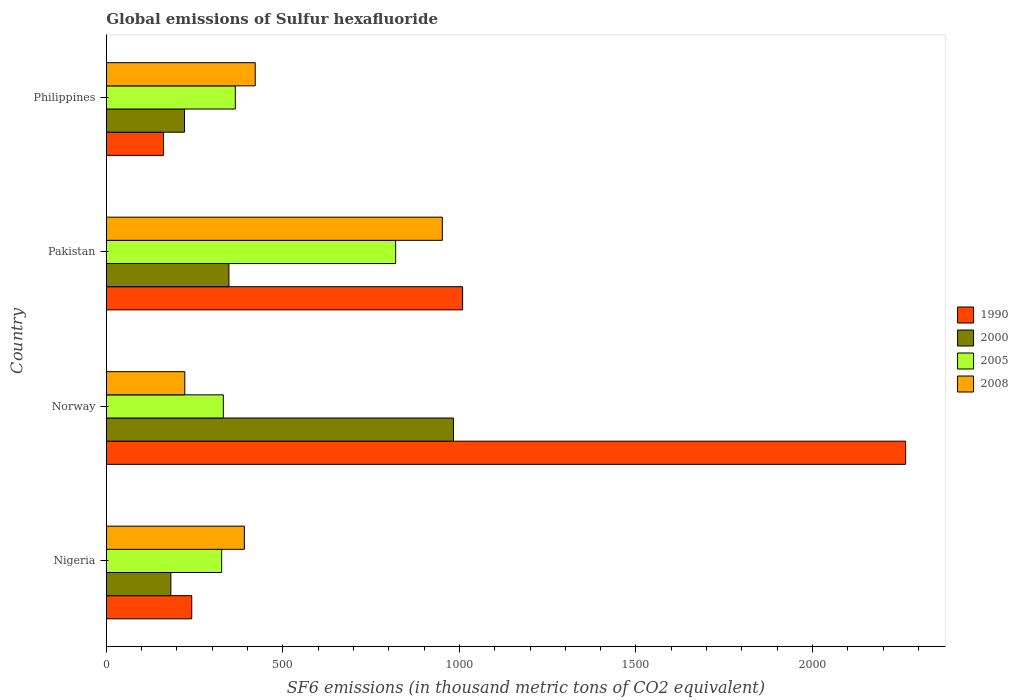How many different coloured bars are there?
Keep it short and to the point. 4. Are the number of bars per tick equal to the number of legend labels?
Your answer should be compact. Yes. How many bars are there on the 4th tick from the bottom?
Offer a very short reply. 4. What is the label of the 1st group of bars from the top?
Your answer should be very brief. Philippines. In how many cases, is the number of bars for a given country not equal to the number of legend labels?
Keep it short and to the point. 0. What is the global emissions of Sulfur hexafluoride in 2005 in Pakistan?
Your response must be concise. 819.4. Across all countries, what is the maximum global emissions of Sulfur hexafluoride in 2008?
Ensure brevity in your answer.  951.6. Across all countries, what is the minimum global emissions of Sulfur hexafluoride in 2005?
Offer a very short reply. 326.6. In which country was the global emissions of Sulfur hexafluoride in 1990 maximum?
Offer a very short reply. Norway. What is the total global emissions of Sulfur hexafluoride in 2000 in the graph?
Make the answer very short. 1734.6. What is the difference between the global emissions of Sulfur hexafluoride in 1990 in Nigeria and that in Norway?
Offer a very short reply. -2021.7. What is the difference between the global emissions of Sulfur hexafluoride in 2000 in Philippines and the global emissions of Sulfur hexafluoride in 2008 in Norway?
Offer a very short reply. -0.8. What is the average global emissions of Sulfur hexafluoride in 2005 per country?
Offer a very short reply. 460.68. What is the difference between the global emissions of Sulfur hexafluoride in 2000 and global emissions of Sulfur hexafluoride in 2005 in Philippines?
Keep it short and to the point. -143.9. What is the ratio of the global emissions of Sulfur hexafluoride in 1990 in Norway to that in Philippines?
Give a very brief answer. 13.98. Is the difference between the global emissions of Sulfur hexafluoride in 2000 in Pakistan and Philippines greater than the difference between the global emissions of Sulfur hexafluoride in 2005 in Pakistan and Philippines?
Provide a succinct answer. No. What is the difference between the highest and the second highest global emissions of Sulfur hexafluoride in 2005?
Offer a terse response. 454.1. What is the difference between the highest and the lowest global emissions of Sulfur hexafluoride in 1990?
Ensure brevity in your answer.  2101.7. Is the sum of the global emissions of Sulfur hexafluoride in 2000 in Nigeria and Pakistan greater than the maximum global emissions of Sulfur hexafluoride in 2008 across all countries?
Give a very brief answer. No. What does the 1st bar from the bottom in Nigeria represents?
Your answer should be compact. 1990. Are all the bars in the graph horizontal?
Provide a succinct answer. Yes. How many countries are there in the graph?
Your answer should be very brief. 4. Does the graph contain any zero values?
Make the answer very short. No. Does the graph contain grids?
Make the answer very short. No. How many legend labels are there?
Your answer should be compact. 4. How are the legend labels stacked?
Make the answer very short. Vertical. What is the title of the graph?
Provide a short and direct response. Global emissions of Sulfur hexafluoride. What is the label or title of the X-axis?
Keep it short and to the point. SF6 emissions (in thousand metric tons of CO2 equivalent). What is the SF6 emissions (in thousand metric tons of CO2 equivalent) in 1990 in Nigeria?
Offer a terse response. 241.9. What is the SF6 emissions (in thousand metric tons of CO2 equivalent) of 2000 in Nigeria?
Provide a short and direct response. 182.8. What is the SF6 emissions (in thousand metric tons of CO2 equivalent) of 2005 in Nigeria?
Your answer should be compact. 326.6. What is the SF6 emissions (in thousand metric tons of CO2 equivalent) in 2008 in Nigeria?
Keep it short and to the point. 390.9. What is the SF6 emissions (in thousand metric tons of CO2 equivalent) of 1990 in Norway?
Offer a terse response. 2263.6. What is the SF6 emissions (in thousand metric tons of CO2 equivalent) of 2000 in Norway?
Make the answer very short. 983.2. What is the SF6 emissions (in thousand metric tons of CO2 equivalent) in 2005 in Norway?
Make the answer very short. 331.4. What is the SF6 emissions (in thousand metric tons of CO2 equivalent) of 2008 in Norway?
Keep it short and to the point. 222.2. What is the SF6 emissions (in thousand metric tons of CO2 equivalent) of 1990 in Pakistan?
Give a very brief answer. 1009. What is the SF6 emissions (in thousand metric tons of CO2 equivalent) in 2000 in Pakistan?
Give a very brief answer. 347.2. What is the SF6 emissions (in thousand metric tons of CO2 equivalent) in 2005 in Pakistan?
Give a very brief answer. 819.4. What is the SF6 emissions (in thousand metric tons of CO2 equivalent) of 2008 in Pakistan?
Your answer should be compact. 951.6. What is the SF6 emissions (in thousand metric tons of CO2 equivalent) in 1990 in Philippines?
Ensure brevity in your answer.  161.9. What is the SF6 emissions (in thousand metric tons of CO2 equivalent) in 2000 in Philippines?
Ensure brevity in your answer.  221.4. What is the SF6 emissions (in thousand metric tons of CO2 equivalent) of 2005 in Philippines?
Your answer should be very brief. 365.3. What is the SF6 emissions (in thousand metric tons of CO2 equivalent) in 2008 in Philippines?
Give a very brief answer. 421.7. Across all countries, what is the maximum SF6 emissions (in thousand metric tons of CO2 equivalent) in 1990?
Provide a succinct answer. 2263.6. Across all countries, what is the maximum SF6 emissions (in thousand metric tons of CO2 equivalent) of 2000?
Ensure brevity in your answer.  983.2. Across all countries, what is the maximum SF6 emissions (in thousand metric tons of CO2 equivalent) in 2005?
Provide a succinct answer. 819.4. Across all countries, what is the maximum SF6 emissions (in thousand metric tons of CO2 equivalent) of 2008?
Give a very brief answer. 951.6. Across all countries, what is the minimum SF6 emissions (in thousand metric tons of CO2 equivalent) of 1990?
Keep it short and to the point. 161.9. Across all countries, what is the minimum SF6 emissions (in thousand metric tons of CO2 equivalent) in 2000?
Provide a succinct answer. 182.8. Across all countries, what is the minimum SF6 emissions (in thousand metric tons of CO2 equivalent) of 2005?
Make the answer very short. 326.6. Across all countries, what is the minimum SF6 emissions (in thousand metric tons of CO2 equivalent) of 2008?
Give a very brief answer. 222.2. What is the total SF6 emissions (in thousand metric tons of CO2 equivalent) of 1990 in the graph?
Give a very brief answer. 3676.4. What is the total SF6 emissions (in thousand metric tons of CO2 equivalent) in 2000 in the graph?
Provide a succinct answer. 1734.6. What is the total SF6 emissions (in thousand metric tons of CO2 equivalent) of 2005 in the graph?
Provide a short and direct response. 1842.7. What is the total SF6 emissions (in thousand metric tons of CO2 equivalent) in 2008 in the graph?
Ensure brevity in your answer.  1986.4. What is the difference between the SF6 emissions (in thousand metric tons of CO2 equivalent) of 1990 in Nigeria and that in Norway?
Keep it short and to the point. -2021.7. What is the difference between the SF6 emissions (in thousand metric tons of CO2 equivalent) in 2000 in Nigeria and that in Norway?
Your answer should be compact. -800.4. What is the difference between the SF6 emissions (in thousand metric tons of CO2 equivalent) of 2005 in Nigeria and that in Norway?
Your answer should be compact. -4.8. What is the difference between the SF6 emissions (in thousand metric tons of CO2 equivalent) of 2008 in Nigeria and that in Norway?
Offer a terse response. 168.7. What is the difference between the SF6 emissions (in thousand metric tons of CO2 equivalent) of 1990 in Nigeria and that in Pakistan?
Give a very brief answer. -767.1. What is the difference between the SF6 emissions (in thousand metric tons of CO2 equivalent) of 2000 in Nigeria and that in Pakistan?
Keep it short and to the point. -164.4. What is the difference between the SF6 emissions (in thousand metric tons of CO2 equivalent) of 2005 in Nigeria and that in Pakistan?
Offer a very short reply. -492.8. What is the difference between the SF6 emissions (in thousand metric tons of CO2 equivalent) of 2008 in Nigeria and that in Pakistan?
Your response must be concise. -560.7. What is the difference between the SF6 emissions (in thousand metric tons of CO2 equivalent) of 1990 in Nigeria and that in Philippines?
Provide a short and direct response. 80. What is the difference between the SF6 emissions (in thousand metric tons of CO2 equivalent) in 2000 in Nigeria and that in Philippines?
Offer a terse response. -38.6. What is the difference between the SF6 emissions (in thousand metric tons of CO2 equivalent) in 2005 in Nigeria and that in Philippines?
Offer a very short reply. -38.7. What is the difference between the SF6 emissions (in thousand metric tons of CO2 equivalent) in 2008 in Nigeria and that in Philippines?
Make the answer very short. -30.8. What is the difference between the SF6 emissions (in thousand metric tons of CO2 equivalent) of 1990 in Norway and that in Pakistan?
Make the answer very short. 1254.6. What is the difference between the SF6 emissions (in thousand metric tons of CO2 equivalent) in 2000 in Norway and that in Pakistan?
Offer a very short reply. 636. What is the difference between the SF6 emissions (in thousand metric tons of CO2 equivalent) in 2005 in Norway and that in Pakistan?
Keep it short and to the point. -488. What is the difference between the SF6 emissions (in thousand metric tons of CO2 equivalent) in 2008 in Norway and that in Pakistan?
Your response must be concise. -729.4. What is the difference between the SF6 emissions (in thousand metric tons of CO2 equivalent) of 1990 in Norway and that in Philippines?
Your answer should be very brief. 2101.7. What is the difference between the SF6 emissions (in thousand metric tons of CO2 equivalent) of 2000 in Norway and that in Philippines?
Your response must be concise. 761.8. What is the difference between the SF6 emissions (in thousand metric tons of CO2 equivalent) in 2005 in Norway and that in Philippines?
Your response must be concise. -33.9. What is the difference between the SF6 emissions (in thousand metric tons of CO2 equivalent) of 2008 in Norway and that in Philippines?
Offer a very short reply. -199.5. What is the difference between the SF6 emissions (in thousand metric tons of CO2 equivalent) in 1990 in Pakistan and that in Philippines?
Ensure brevity in your answer.  847.1. What is the difference between the SF6 emissions (in thousand metric tons of CO2 equivalent) in 2000 in Pakistan and that in Philippines?
Provide a succinct answer. 125.8. What is the difference between the SF6 emissions (in thousand metric tons of CO2 equivalent) of 2005 in Pakistan and that in Philippines?
Provide a succinct answer. 454.1. What is the difference between the SF6 emissions (in thousand metric tons of CO2 equivalent) in 2008 in Pakistan and that in Philippines?
Your answer should be very brief. 529.9. What is the difference between the SF6 emissions (in thousand metric tons of CO2 equivalent) in 1990 in Nigeria and the SF6 emissions (in thousand metric tons of CO2 equivalent) in 2000 in Norway?
Provide a succinct answer. -741.3. What is the difference between the SF6 emissions (in thousand metric tons of CO2 equivalent) in 1990 in Nigeria and the SF6 emissions (in thousand metric tons of CO2 equivalent) in 2005 in Norway?
Your answer should be very brief. -89.5. What is the difference between the SF6 emissions (in thousand metric tons of CO2 equivalent) of 1990 in Nigeria and the SF6 emissions (in thousand metric tons of CO2 equivalent) of 2008 in Norway?
Your answer should be very brief. 19.7. What is the difference between the SF6 emissions (in thousand metric tons of CO2 equivalent) in 2000 in Nigeria and the SF6 emissions (in thousand metric tons of CO2 equivalent) in 2005 in Norway?
Make the answer very short. -148.6. What is the difference between the SF6 emissions (in thousand metric tons of CO2 equivalent) in 2000 in Nigeria and the SF6 emissions (in thousand metric tons of CO2 equivalent) in 2008 in Norway?
Your response must be concise. -39.4. What is the difference between the SF6 emissions (in thousand metric tons of CO2 equivalent) in 2005 in Nigeria and the SF6 emissions (in thousand metric tons of CO2 equivalent) in 2008 in Norway?
Make the answer very short. 104.4. What is the difference between the SF6 emissions (in thousand metric tons of CO2 equivalent) in 1990 in Nigeria and the SF6 emissions (in thousand metric tons of CO2 equivalent) in 2000 in Pakistan?
Offer a terse response. -105.3. What is the difference between the SF6 emissions (in thousand metric tons of CO2 equivalent) in 1990 in Nigeria and the SF6 emissions (in thousand metric tons of CO2 equivalent) in 2005 in Pakistan?
Give a very brief answer. -577.5. What is the difference between the SF6 emissions (in thousand metric tons of CO2 equivalent) of 1990 in Nigeria and the SF6 emissions (in thousand metric tons of CO2 equivalent) of 2008 in Pakistan?
Your answer should be very brief. -709.7. What is the difference between the SF6 emissions (in thousand metric tons of CO2 equivalent) in 2000 in Nigeria and the SF6 emissions (in thousand metric tons of CO2 equivalent) in 2005 in Pakistan?
Keep it short and to the point. -636.6. What is the difference between the SF6 emissions (in thousand metric tons of CO2 equivalent) of 2000 in Nigeria and the SF6 emissions (in thousand metric tons of CO2 equivalent) of 2008 in Pakistan?
Offer a very short reply. -768.8. What is the difference between the SF6 emissions (in thousand metric tons of CO2 equivalent) in 2005 in Nigeria and the SF6 emissions (in thousand metric tons of CO2 equivalent) in 2008 in Pakistan?
Ensure brevity in your answer.  -625. What is the difference between the SF6 emissions (in thousand metric tons of CO2 equivalent) in 1990 in Nigeria and the SF6 emissions (in thousand metric tons of CO2 equivalent) in 2000 in Philippines?
Your answer should be very brief. 20.5. What is the difference between the SF6 emissions (in thousand metric tons of CO2 equivalent) of 1990 in Nigeria and the SF6 emissions (in thousand metric tons of CO2 equivalent) of 2005 in Philippines?
Give a very brief answer. -123.4. What is the difference between the SF6 emissions (in thousand metric tons of CO2 equivalent) of 1990 in Nigeria and the SF6 emissions (in thousand metric tons of CO2 equivalent) of 2008 in Philippines?
Provide a succinct answer. -179.8. What is the difference between the SF6 emissions (in thousand metric tons of CO2 equivalent) of 2000 in Nigeria and the SF6 emissions (in thousand metric tons of CO2 equivalent) of 2005 in Philippines?
Make the answer very short. -182.5. What is the difference between the SF6 emissions (in thousand metric tons of CO2 equivalent) of 2000 in Nigeria and the SF6 emissions (in thousand metric tons of CO2 equivalent) of 2008 in Philippines?
Your answer should be compact. -238.9. What is the difference between the SF6 emissions (in thousand metric tons of CO2 equivalent) of 2005 in Nigeria and the SF6 emissions (in thousand metric tons of CO2 equivalent) of 2008 in Philippines?
Your response must be concise. -95.1. What is the difference between the SF6 emissions (in thousand metric tons of CO2 equivalent) of 1990 in Norway and the SF6 emissions (in thousand metric tons of CO2 equivalent) of 2000 in Pakistan?
Your response must be concise. 1916.4. What is the difference between the SF6 emissions (in thousand metric tons of CO2 equivalent) of 1990 in Norway and the SF6 emissions (in thousand metric tons of CO2 equivalent) of 2005 in Pakistan?
Give a very brief answer. 1444.2. What is the difference between the SF6 emissions (in thousand metric tons of CO2 equivalent) in 1990 in Norway and the SF6 emissions (in thousand metric tons of CO2 equivalent) in 2008 in Pakistan?
Your response must be concise. 1312. What is the difference between the SF6 emissions (in thousand metric tons of CO2 equivalent) in 2000 in Norway and the SF6 emissions (in thousand metric tons of CO2 equivalent) in 2005 in Pakistan?
Keep it short and to the point. 163.8. What is the difference between the SF6 emissions (in thousand metric tons of CO2 equivalent) in 2000 in Norway and the SF6 emissions (in thousand metric tons of CO2 equivalent) in 2008 in Pakistan?
Ensure brevity in your answer.  31.6. What is the difference between the SF6 emissions (in thousand metric tons of CO2 equivalent) in 2005 in Norway and the SF6 emissions (in thousand metric tons of CO2 equivalent) in 2008 in Pakistan?
Your answer should be compact. -620.2. What is the difference between the SF6 emissions (in thousand metric tons of CO2 equivalent) in 1990 in Norway and the SF6 emissions (in thousand metric tons of CO2 equivalent) in 2000 in Philippines?
Offer a very short reply. 2042.2. What is the difference between the SF6 emissions (in thousand metric tons of CO2 equivalent) of 1990 in Norway and the SF6 emissions (in thousand metric tons of CO2 equivalent) of 2005 in Philippines?
Provide a short and direct response. 1898.3. What is the difference between the SF6 emissions (in thousand metric tons of CO2 equivalent) of 1990 in Norway and the SF6 emissions (in thousand metric tons of CO2 equivalent) of 2008 in Philippines?
Offer a terse response. 1841.9. What is the difference between the SF6 emissions (in thousand metric tons of CO2 equivalent) in 2000 in Norway and the SF6 emissions (in thousand metric tons of CO2 equivalent) in 2005 in Philippines?
Offer a terse response. 617.9. What is the difference between the SF6 emissions (in thousand metric tons of CO2 equivalent) of 2000 in Norway and the SF6 emissions (in thousand metric tons of CO2 equivalent) of 2008 in Philippines?
Your answer should be very brief. 561.5. What is the difference between the SF6 emissions (in thousand metric tons of CO2 equivalent) in 2005 in Norway and the SF6 emissions (in thousand metric tons of CO2 equivalent) in 2008 in Philippines?
Offer a terse response. -90.3. What is the difference between the SF6 emissions (in thousand metric tons of CO2 equivalent) of 1990 in Pakistan and the SF6 emissions (in thousand metric tons of CO2 equivalent) of 2000 in Philippines?
Offer a very short reply. 787.6. What is the difference between the SF6 emissions (in thousand metric tons of CO2 equivalent) in 1990 in Pakistan and the SF6 emissions (in thousand metric tons of CO2 equivalent) in 2005 in Philippines?
Your response must be concise. 643.7. What is the difference between the SF6 emissions (in thousand metric tons of CO2 equivalent) of 1990 in Pakistan and the SF6 emissions (in thousand metric tons of CO2 equivalent) of 2008 in Philippines?
Make the answer very short. 587.3. What is the difference between the SF6 emissions (in thousand metric tons of CO2 equivalent) in 2000 in Pakistan and the SF6 emissions (in thousand metric tons of CO2 equivalent) in 2005 in Philippines?
Give a very brief answer. -18.1. What is the difference between the SF6 emissions (in thousand metric tons of CO2 equivalent) of 2000 in Pakistan and the SF6 emissions (in thousand metric tons of CO2 equivalent) of 2008 in Philippines?
Provide a short and direct response. -74.5. What is the difference between the SF6 emissions (in thousand metric tons of CO2 equivalent) of 2005 in Pakistan and the SF6 emissions (in thousand metric tons of CO2 equivalent) of 2008 in Philippines?
Provide a short and direct response. 397.7. What is the average SF6 emissions (in thousand metric tons of CO2 equivalent) in 1990 per country?
Give a very brief answer. 919.1. What is the average SF6 emissions (in thousand metric tons of CO2 equivalent) of 2000 per country?
Provide a short and direct response. 433.65. What is the average SF6 emissions (in thousand metric tons of CO2 equivalent) of 2005 per country?
Your answer should be very brief. 460.68. What is the average SF6 emissions (in thousand metric tons of CO2 equivalent) in 2008 per country?
Provide a succinct answer. 496.6. What is the difference between the SF6 emissions (in thousand metric tons of CO2 equivalent) of 1990 and SF6 emissions (in thousand metric tons of CO2 equivalent) of 2000 in Nigeria?
Your answer should be compact. 59.1. What is the difference between the SF6 emissions (in thousand metric tons of CO2 equivalent) of 1990 and SF6 emissions (in thousand metric tons of CO2 equivalent) of 2005 in Nigeria?
Offer a very short reply. -84.7. What is the difference between the SF6 emissions (in thousand metric tons of CO2 equivalent) in 1990 and SF6 emissions (in thousand metric tons of CO2 equivalent) in 2008 in Nigeria?
Your answer should be very brief. -149. What is the difference between the SF6 emissions (in thousand metric tons of CO2 equivalent) of 2000 and SF6 emissions (in thousand metric tons of CO2 equivalent) of 2005 in Nigeria?
Offer a terse response. -143.8. What is the difference between the SF6 emissions (in thousand metric tons of CO2 equivalent) in 2000 and SF6 emissions (in thousand metric tons of CO2 equivalent) in 2008 in Nigeria?
Make the answer very short. -208.1. What is the difference between the SF6 emissions (in thousand metric tons of CO2 equivalent) of 2005 and SF6 emissions (in thousand metric tons of CO2 equivalent) of 2008 in Nigeria?
Your answer should be very brief. -64.3. What is the difference between the SF6 emissions (in thousand metric tons of CO2 equivalent) of 1990 and SF6 emissions (in thousand metric tons of CO2 equivalent) of 2000 in Norway?
Offer a very short reply. 1280.4. What is the difference between the SF6 emissions (in thousand metric tons of CO2 equivalent) of 1990 and SF6 emissions (in thousand metric tons of CO2 equivalent) of 2005 in Norway?
Give a very brief answer. 1932.2. What is the difference between the SF6 emissions (in thousand metric tons of CO2 equivalent) of 1990 and SF6 emissions (in thousand metric tons of CO2 equivalent) of 2008 in Norway?
Your response must be concise. 2041.4. What is the difference between the SF6 emissions (in thousand metric tons of CO2 equivalent) in 2000 and SF6 emissions (in thousand metric tons of CO2 equivalent) in 2005 in Norway?
Offer a terse response. 651.8. What is the difference between the SF6 emissions (in thousand metric tons of CO2 equivalent) of 2000 and SF6 emissions (in thousand metric tons of CO2 equivalent) of 2008 in Norway?
Your response must be concise. 761. What is the difference between the SF6 emissions (in thousand metric tons of CO2 equivalent) in 2005 and SF6 emissions (in thousand metric tons of CO2 equivalent) in 2008 in Norway?
Your response must be concise. 109.2. What is the difference between the SF6 emissions (in thousand metric tons of CO2 equivalent) in 1990 and SF6 emissions (in thousand metric tons of CO2 equivalent) in 2000 in Pakistan?
Provide a short and direct response. 661.8. What is the difference between the SF6 emissions (in thousand metric tons of CO2 equivalent) in 1990 and SF6 emissions (in thousand metric tons of CO2 equivalent) in 2005 in Pakistan?
Make the answer very short. 189.6. What is the difference between the SF6 emissions (in thousand metric tons of CO2 equivalent) of 1990 and SF6 emissions (in thousand metric tons of CO2 equivalent) of 2008 in Pakistan?
Your answer should be compact. 57.4. What is the difference between the SF6 emissions (in thousand metric tons of CO2 equivalent) of 2000 and SF6 emissions (in thousand metric tons of CO2 equivalent) of 2005 in Pakistan?
Offer a terse response. -472.2. What is the difference between the SF6 emissions (in thousand metric tons of CO2 equivalent) in 2000 and SF6 emissions (in thousand metric tons of CO2 equivalent) in 2008 in Pakistan?
Provide a short and direct response. -604.4. What is the difference between the SF6 emissions (in thousand metric tons of CO2 equivalent) in 2005 and SF6 emissions (in thousand metric tons of CO2 equivalent) in 2008 in Pakistan?
Give a very brief answer. -132.2. What is the difference between the SF6 emissions (in thousand metric tons of CO2 equivalent) in 1990 and SF6 emissions (in thousand metric tons of CO2 equivalent) in 2000 in Philippines?
Keep it short and to the point. -59.5. What is the difference between the SF6 emissions (in thousand metric tons of CO2 equivalent) of 1990 and SF6 emissions (in thousand metric tons of CO2 equivalent) of 2005 in Philippines?
Your answer should be very brief. -203.4. What is the difference between the SF6 emissions (in thousand metric tons of CO2 equivalent) in 1990 and SF6 emissions (in thousand metric tons of CO2 equivalent) in 2008 in Philippines?
Give a very brief answer. -259.8. What is the difference between the SF6 emissions (in thousand metric tons of CO2 equivalent) of 2000 and SF6 emissions (in thousand metric tons of CO2 equivalent) of 2005 in Philippines?
Ensure brevity in your answer.  -143.9. What is the difference between the SF6 emissions (in thousand metric tons of CO2 equivalent) of 2000 and SF6 emissions (in thousand metric tons of CO2 equivalent) of 2008 in Philippines?
Your response must be concise. -200.3. What is the difference between the SF6 emissions (in thousand metric tons of CO2 equivalent) of 2005 and SF6 emissions (in thousand metric tons of CO2 equivalent) of 2008 in Philippines?
Offer a very short reply. -56.4. What is the ratio of the SF6 emissions (in thousand metric tons of CO2 equivalent) in 1990 in Nigeria to that in Norway?
Provide a short and direct response. 0.11. What is the ratio of the SF6 emissions (in thousand metric tons of CO2 equivalent) of 2000 in Nigeria to that in Norway?
Your answer should be compact. 0.19. What is the ratio of the SF6 emissions (in thousand metric tons of CO2 equivalent) in 2005 in Nigeria to that in Norway?
Ensure brevity in your answer.  0.99. What is the ratio of the SF6 emissions (in thousand metric tons of CO2 equivalent) of 2008 in Nigeria to that in Norway?
Offer a terse response. 1.76. What is the ratio of the SF6 emissions (in thousand metric tons of CO2 equivalent) in 1990 in Nigeria to that in Pakistan?
Your response must be concise. 0.24. What is the ratio of the SF6 emissions (in thousand metric tons of CO2 equivalent) of 2000 in Nigeria to that in Pakistan?
Your answer should be very brief. 0.53. What is the ratio of the SF6 emissions (in thousand metric tons of CO2 equivalent) in 2005 in Nigeria to that in Pakistan?
Your answer should be very brief. 0.4. What is the ratio of the SF6 emissions (in thousand metric tons of CO2 equivalent) in 2008 in Nigeria to that in Pakistan?
Give a very brief answer. 0.41. What is the ratio of the SF6 emissions (in thousand metric tons of CO2 equivalent) of 1990 in Nigeria to that in Philippines?
Your answer should be very brief. 1.49. What is the ratio of the SF6 emissions (in thousand metric tons of CO2 equivalent) of 2000 in Nigeria to that in Philippines?
Your response must be concise. 0.83. What is the ratio of the SF6 emissions (in thousand metric tons of CO2 equivalent) of 2005 in Nigeria to that in Philippines?
Give a very brief answer. 0.89. What is the ratio of the SF6 emissions (in thousand metric tons of CO2 equivalent) of 2008 in Nigeria to that in Philippines?
Give a very brief answer. 0.93. What is the ratio of the SF6 emissions (in thousand metric tons of CO2 equivalent) of 1990 in Norway to that in Pakistan?
Your answer should be compact. 2.24. What is the ratio of the SF6 emissions (in thousand metric tons of CO2 equivalent) in 2000 in Norway to that in Pakistan?
Provide a succinct answer. 2.83. What is the ratio of the SF6 emissions (in thousand metric tons of CO2 equivalent) in 2005 in Norway to that in Pakistan?
Offer a very short reply. 0.4. What is the ratio of the SF6 emissions (in thousand metric tons of CO2 equivalent) of 2008 in Norway to that in Pakistan?
Your answer should be very brief. 0.23. What is the ratio of the SF6 emissions (in thousand metric tons of CO2 equivalent) in 1990 in Norway to that in Philippines?
Your answer should be very brief. 13.98. What is the ratio of the SF6 emissions (in thousand metric tons of CO2 equivalent) of 2000 in Norway to that in Philippines?
Keep it short and to the point. 4.44. What is the ratio of the SF6 emissions (in thousand metric tons of CO2 equivalent) of 2005 in Norway to that in Philippines?
Your answer should be compact. 0.91. What is the ratio of the SF6 emissions (in thousand metric tons of CO2 equivalent) in 2008 in Norway to that in Philippines?
Provide a short and direct response. 0.53. What is the ratio of the SF6 emissions (in thousand metric tons of CO2 equivalent) of 1990 in Pakistan to that in Philippines?
Give a very brief answer. 6.23. What is the ratio of the SF6 emissions (in thousand metric tons of CO2 equivalent) in 2000 in Pakistan to that in Philippines?
Offer a very short reply. 1.57. What is the ratio of the SF6 emissions (in thousand metric tons of CO2 equivalent) in 2005 in Pakistan to that in Philippines?
Provide a succinct answer. 2.24. What is the ratio of the SF6 emissions (in thousand metric tons of CO2 equivalent) in 2008 in Pakistan to that in Philippines?
Ensure brevity in your answer.  2.26. What is the difference between the highest and the second highest SF6 emissions (in thousand metric tons of CO2 equivalent) of 1990?
Provide a succinct answer. 1254.6. What is the difference between the highest and the second highest SF6 emissions (in thousand metric tons of CO2 equivalent) in 2000?
Make the answer very short. 636. What is the difference between the highest and the second highest SF6 emissions (in thousand metric tons of CO2 equivalent) in 2005?
Provide a short and direct response. 454.1. What is the difference between the highest and the second highest SF6 emissions (in thousand metric tons of CO2 equivalent) of 2008?
Your answer should be compact. 529.9. What is the difference between the highest and the lowest SF6 emissions (in thousand metric tons of CO2 equivalent) in 1990?
Your answer should be very brief. 2101.7. What is the difference between the highest and the lowest SF6 emissions (in thousand metric tons of CO2 equivalent) in 2000?
Your response must be concise. 800.4. What is the difference between the highest and the lowest SF6 emissions (in thousand metric tons of CO2 equivalent) of 2005?
Provide a short and direct response. 492.8. What is the difference between the highest and the lowest SF6 emissions (in thousand metric tons of CO2 equivalent) in 2008?
Make the answer very short. 729.4. 